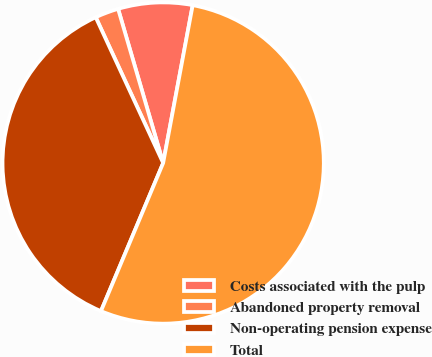<chart> <loc_0><loc_0><loc_500><loc_500><pie_chart><fcel>Costs associated with the pulp<fcel>Abandoned property removal<fcel>Non-operating pension expense<fcel>Total<nl><fcel>7.47%<fcel>2.37%<fcel>36.77%<fcel>53.38%<nl></chart> 